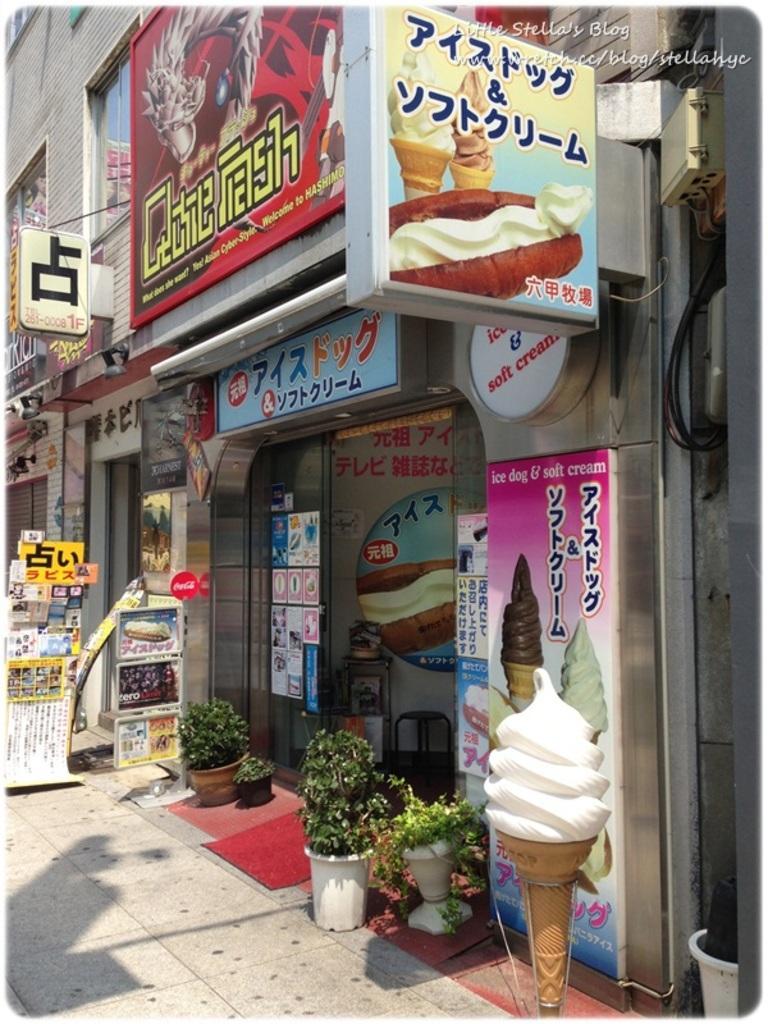In one or two sentences, can you explain what this image depicts? This image is taken outdoors. At the bottom of the image there is a floor. On the right side of the image there is an artificial ice cream. In this image there are many boards with text and images on them. On the left side of the image there a few books. In the middle of the image there are a few plants in the pots. In the background there is a building. 